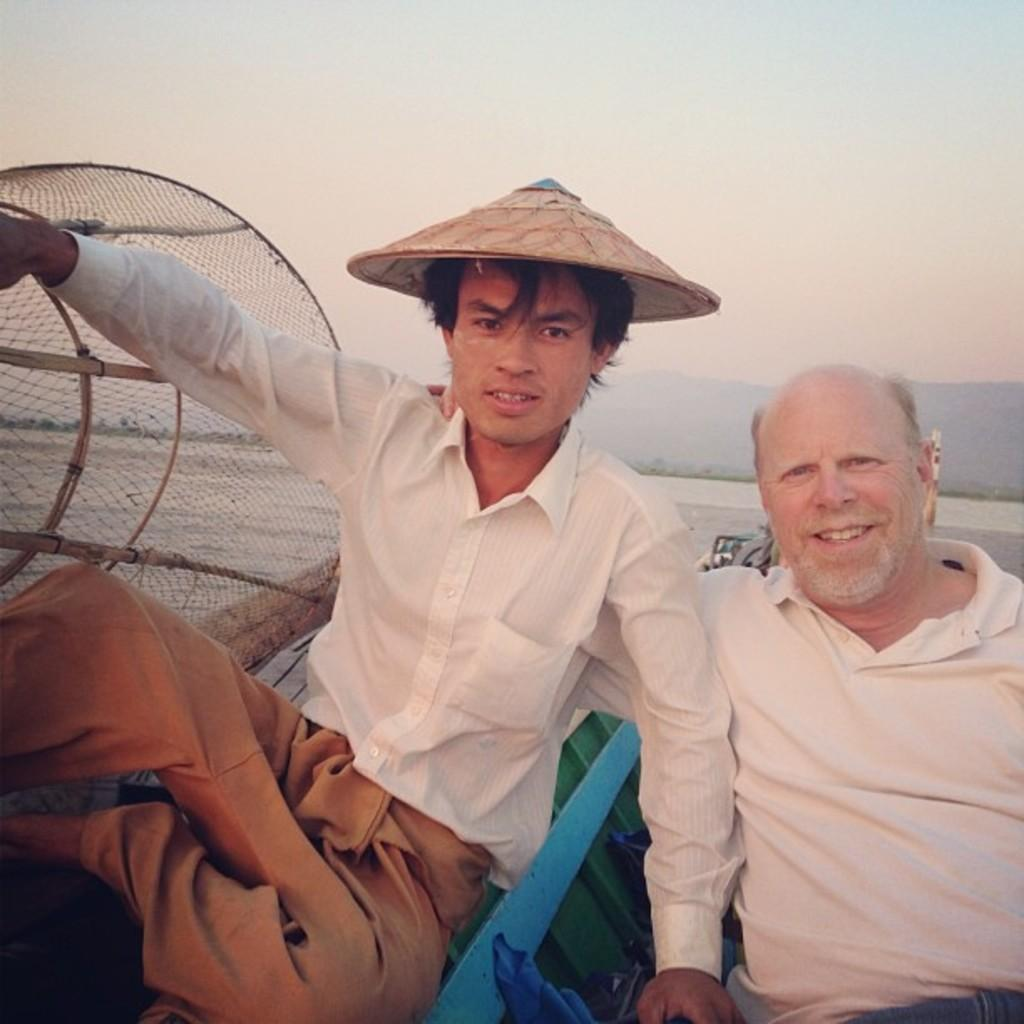How many people are in the image? There are two people in the image. What are the people doing in the image? The people are sitting on a boat. Where is the boat located? The boat is on a river. What object is beside one of the people? There is an object like a net beside the person. What can be seen in the background of the image? There are mountains and the sky visible in the background of the image. What type of hydrant can be seen near the mountains in the image? There is no hydrant present in the image; it features two people sitting on a boat on a river with mountains and the sky visible in the background. Can you tell me the name of the judge who is overseeing the activity in the image? There is no judge present in the image, as it depicts two people sitting on a boat on a river with an object like a net beside one of them. 